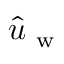Convert formula to latex. <formula><loc_0><loc_0><loc_500><loc_500>\hat { u } _ { w }</formula> 